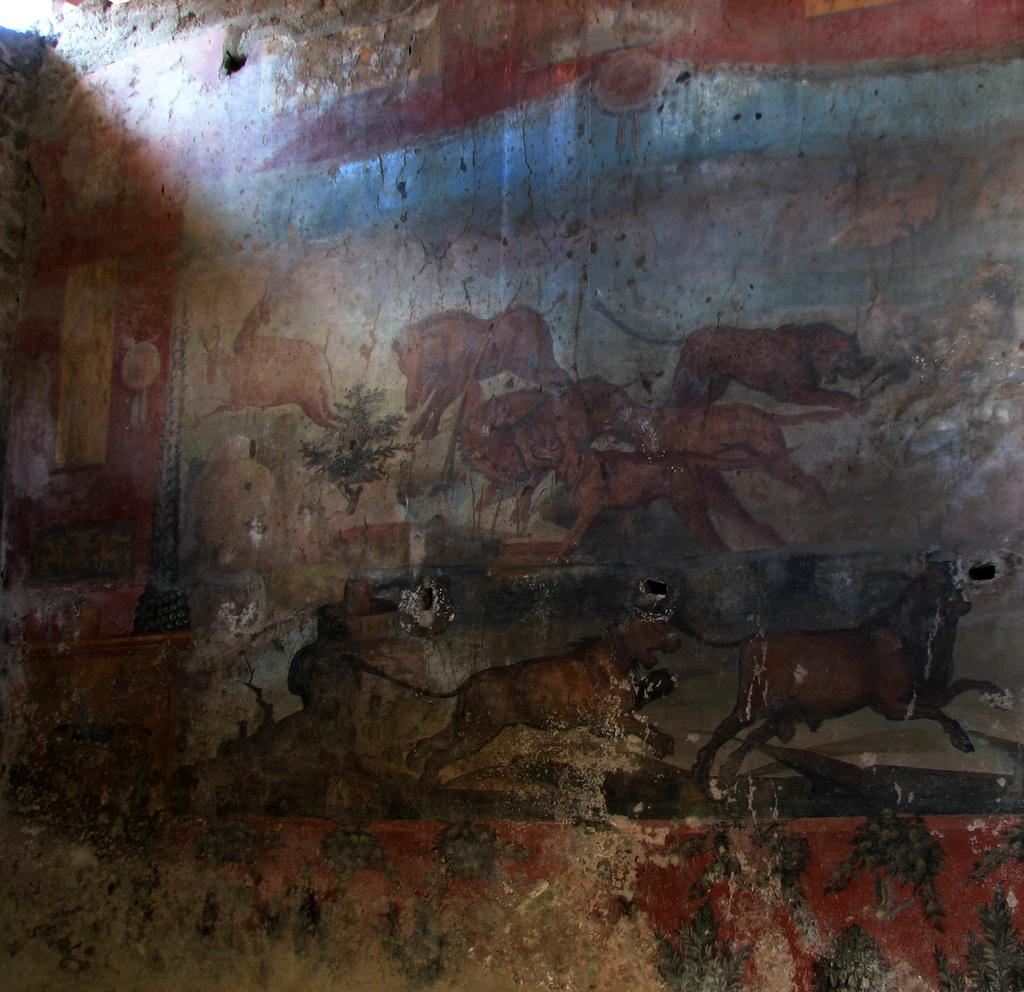What can be seen in the top left of the image? There is a light in the top left of the image. What is depicted on the wall in the image? There is a painting on a wall in the image. What types of animals are included in the painting? The painting contains animals. What other elements are present in the painting? The painting contains trees and other objects. What type of whip is being used by the animals in the painting? There is no whip present in the painting; it only contains animals, trees, and other objects. What color is the dress worn by the trees in the painting? There is no dress present in the painting, as trees are not typically associated with clothing. 